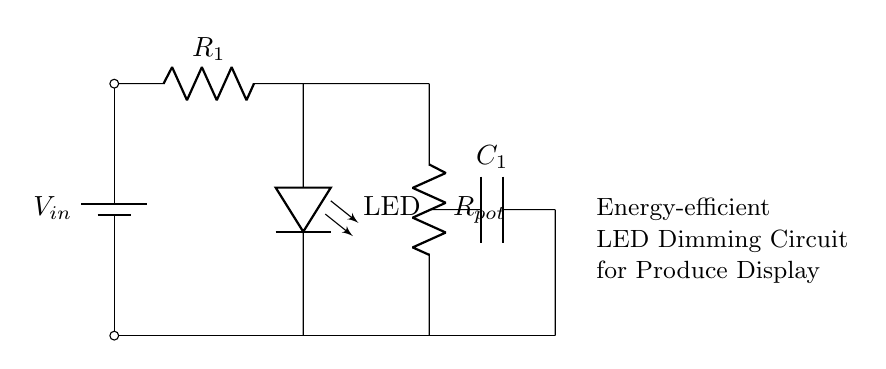What is the voltage source in this circuit? The voltage source is identified as V_in, located at the top of the circuit diagram. It provides the necessary potential difference for the circuit to function.
Answer: V_in What components are used in this dimming circuit? The circuit comprises a battery (V_in), a resistor (R_1), a potentiometer (R_pot), a capacitor (C_1), and an LED. Each component plays a vital role in controlling the dimming and charging functions of the circuit.
Answer: Battery, resistor, potentiometer, capacitor, LED What is the purpose of the capacitor in this circuit? The capacitor (C_1) is used to smooth out the fluctuating current from the power supply and improve the energy efficiency of the LED dimming by storing and releasing charge as needed.
Answer: Smoothing current What function does the potentiometer serve in this circuit? The potentiometer (R_pot) allows for adjustable resistance, enabling the user to control the brightness of the LED by varying the resistance in the circuit. This adjustability is crucial for different display lighting conditions.
Answer: Adjustable resistance How many branches are in this circuit? The circuit has two main branches: one for the LED (with R_1) and another containing the potentiometer and the capacitor. Both branches are connected to the voltage source, allowing current to flow through the different components.
Answer: Two What characteristic of the LED can affect its brightness? The brightness of the LED is affected by the current passing through it. The amount of current is controlled by the values of R_1 and R_pot in the circuit, as reducing resistance increases current and thereby brightness.
Answer: Current passing through What happens to the LED brightness when the potentiometer is turned down? When the potentiometer is turned down (increasing resistance), the current flowing through the LED decreases, which leads to a reduction in brightness. This functionality is essential for dimming the light to suit various display needs.
Answer: Brightness decreases 